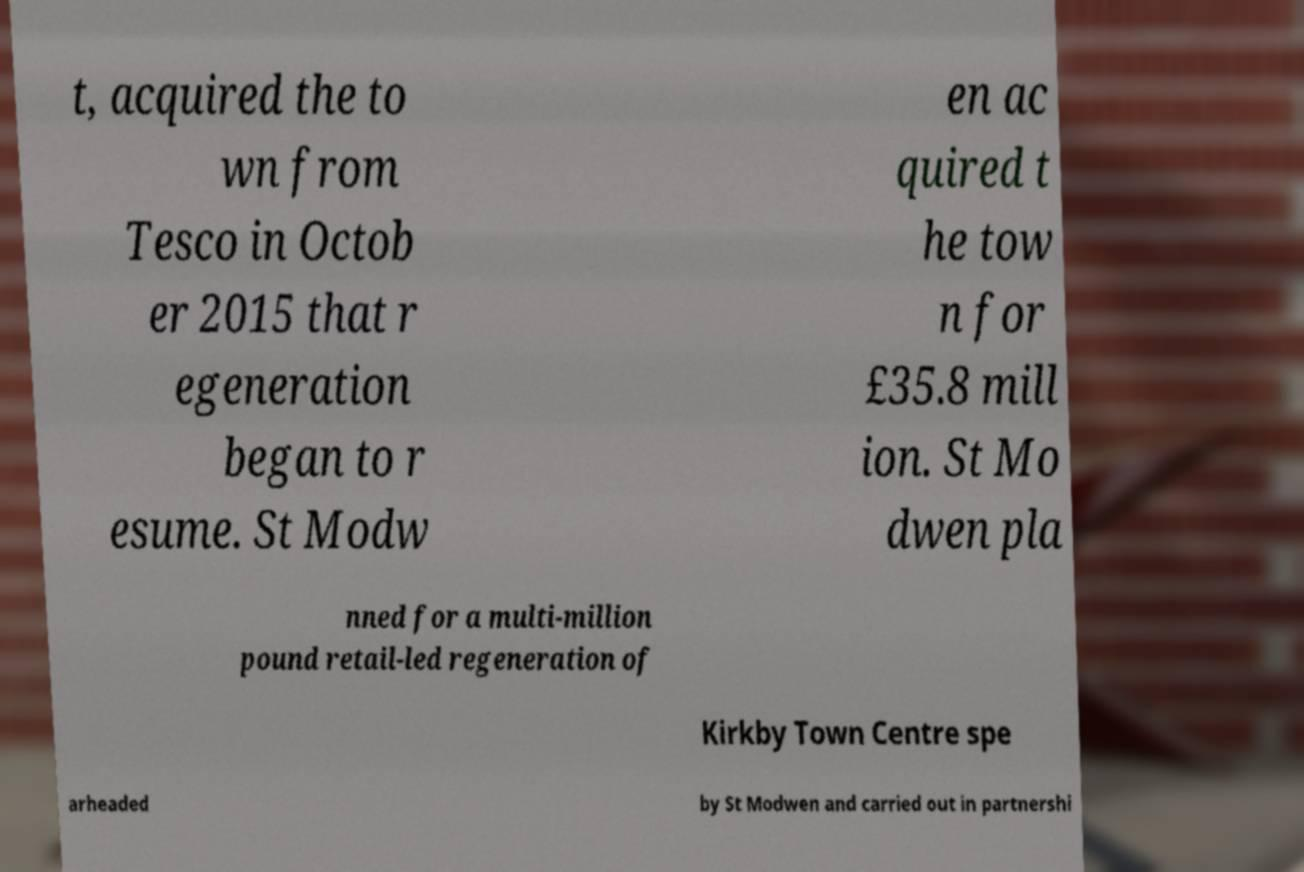Can you accurately transcribe the text from the provided image for me? t, acquired the to wn from Tesco in Octob er 2015 that r egeneration began to r esume. St Modw en ac quired t he tow n for £35.8 mill ion. St Mo dwen pla nned for a multi-million pound retail-led regeneration of Kirkby Town Centre spe arheaded by St Modwen and carried out in partnershi 